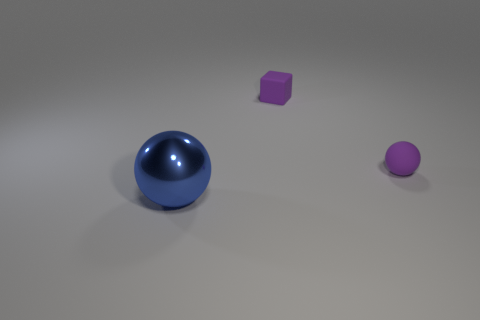Add 1 big balls. How many objects exist? 4 Subtract all balls. How many objects are left? 1 Subtract all metallic spheres. Subtract all small spheres. How many objects are left? 1 Add 1 tiny purple balls. How many tiny purple balls are left? 2 Add 3 big cyan rubber objects. How many big cyan rubber objects exist? 3 Subtract 0 blue cylinders. How many objects are left? 3 